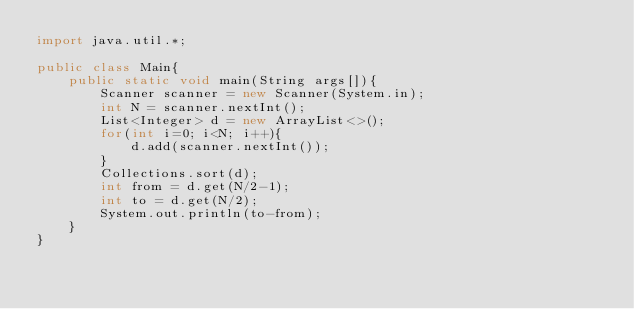Convert code to text. <code><loc_0><loc_0><loc_500><loc_500><_Java_>import java.util.*;

public class Main{
    public static void main(String args[]){
        Scanner scanner = new Scanner(System.in);
        int N = scanner.nextInt();
        List<Integer> d = new ArrayList<>();
        for(int i=0; i<N; i++){
            d.add(scanner.nextInt());
        }
        Collections.sort(d);
        int from = d.get(N/2-1);
        int to = d.get(N/2);
        System.out.println(to-from);
    }
}</code> 